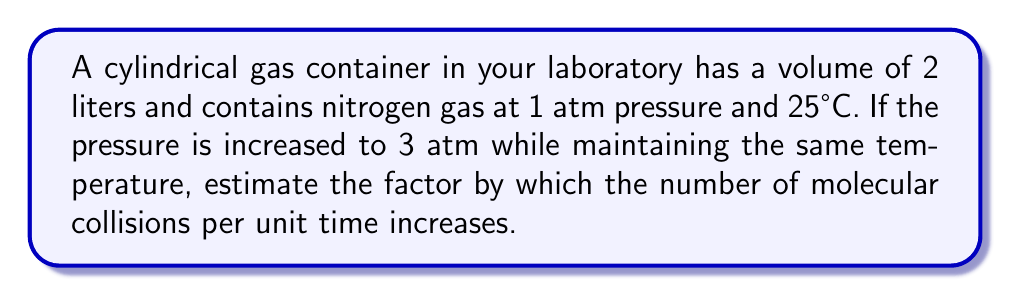What is the answer to this math problem? To solve this problem, we'll follow these steps:

1) The number of molecular collisions per unit time is proportional to the square of the gas density and the average molecular speed.

2) At constant temperature, the average molecular speed remains unchanged.

3) The density of the gas is directly proportional to the pressure at constant temperature (according to Boyle's Law).

4) Let's define:
   $n_1$ = number of collisions at 1 atm
   $n_2$ = number of collisions at 3 atm
   $\rho_1$ = density at 1 atm
   $\rho_2$ = density at 3 atm

5) We can write:
   $$\frac{n_2}{n_1} = \left(\frac{\rho_2}{\rho_1}\right)^2$$

6) From Boyle's Law:
   $$\frac{\rho_2}{\rho_1} = \frac{P_2}{P_1} = \frac{3 \text{ atm}}{1 \text{ atm}} = 3$$

7) Substituting this into our equation:
   $$\frac{n_2}{n_1} = (3)^2 = 9$$

Therefore, the number of molecular collisions per unit time increases by a factor of 9.
Answer: 9 